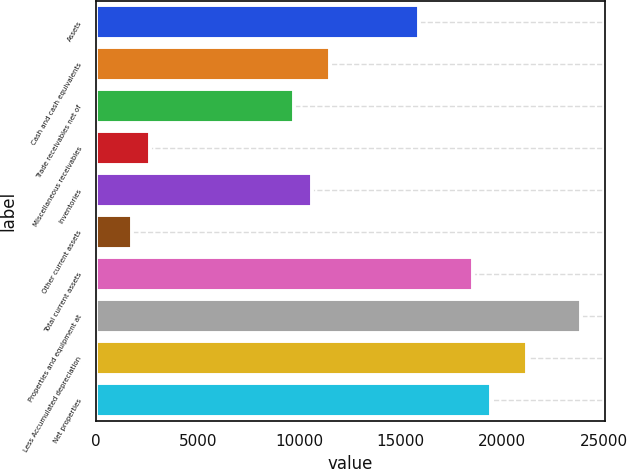Convert chart. <chart><loc_0><loc_0><loc_500><loc_500><bar_chart><fcel>Assets<fcel>Cash and cash equivalents<fcel>Trade receivables net of<fcel>Miscellaneous receivables<fcel>Inventories<fcel>Other current assets<fcel>Total current assets<fcel>Properties and equipment at<fcel>Less Accumulated depreciation<fcel>Net properties<nl><fcel>15918.4<fcel>11496.9<fcel>9728.3<fcel>2653.9<fcel>10612.6<fcel>1769.6<fcel>18571.3<fcel>23877.1<fcel>21224.2<fcel>19455.6<nl></chart> 